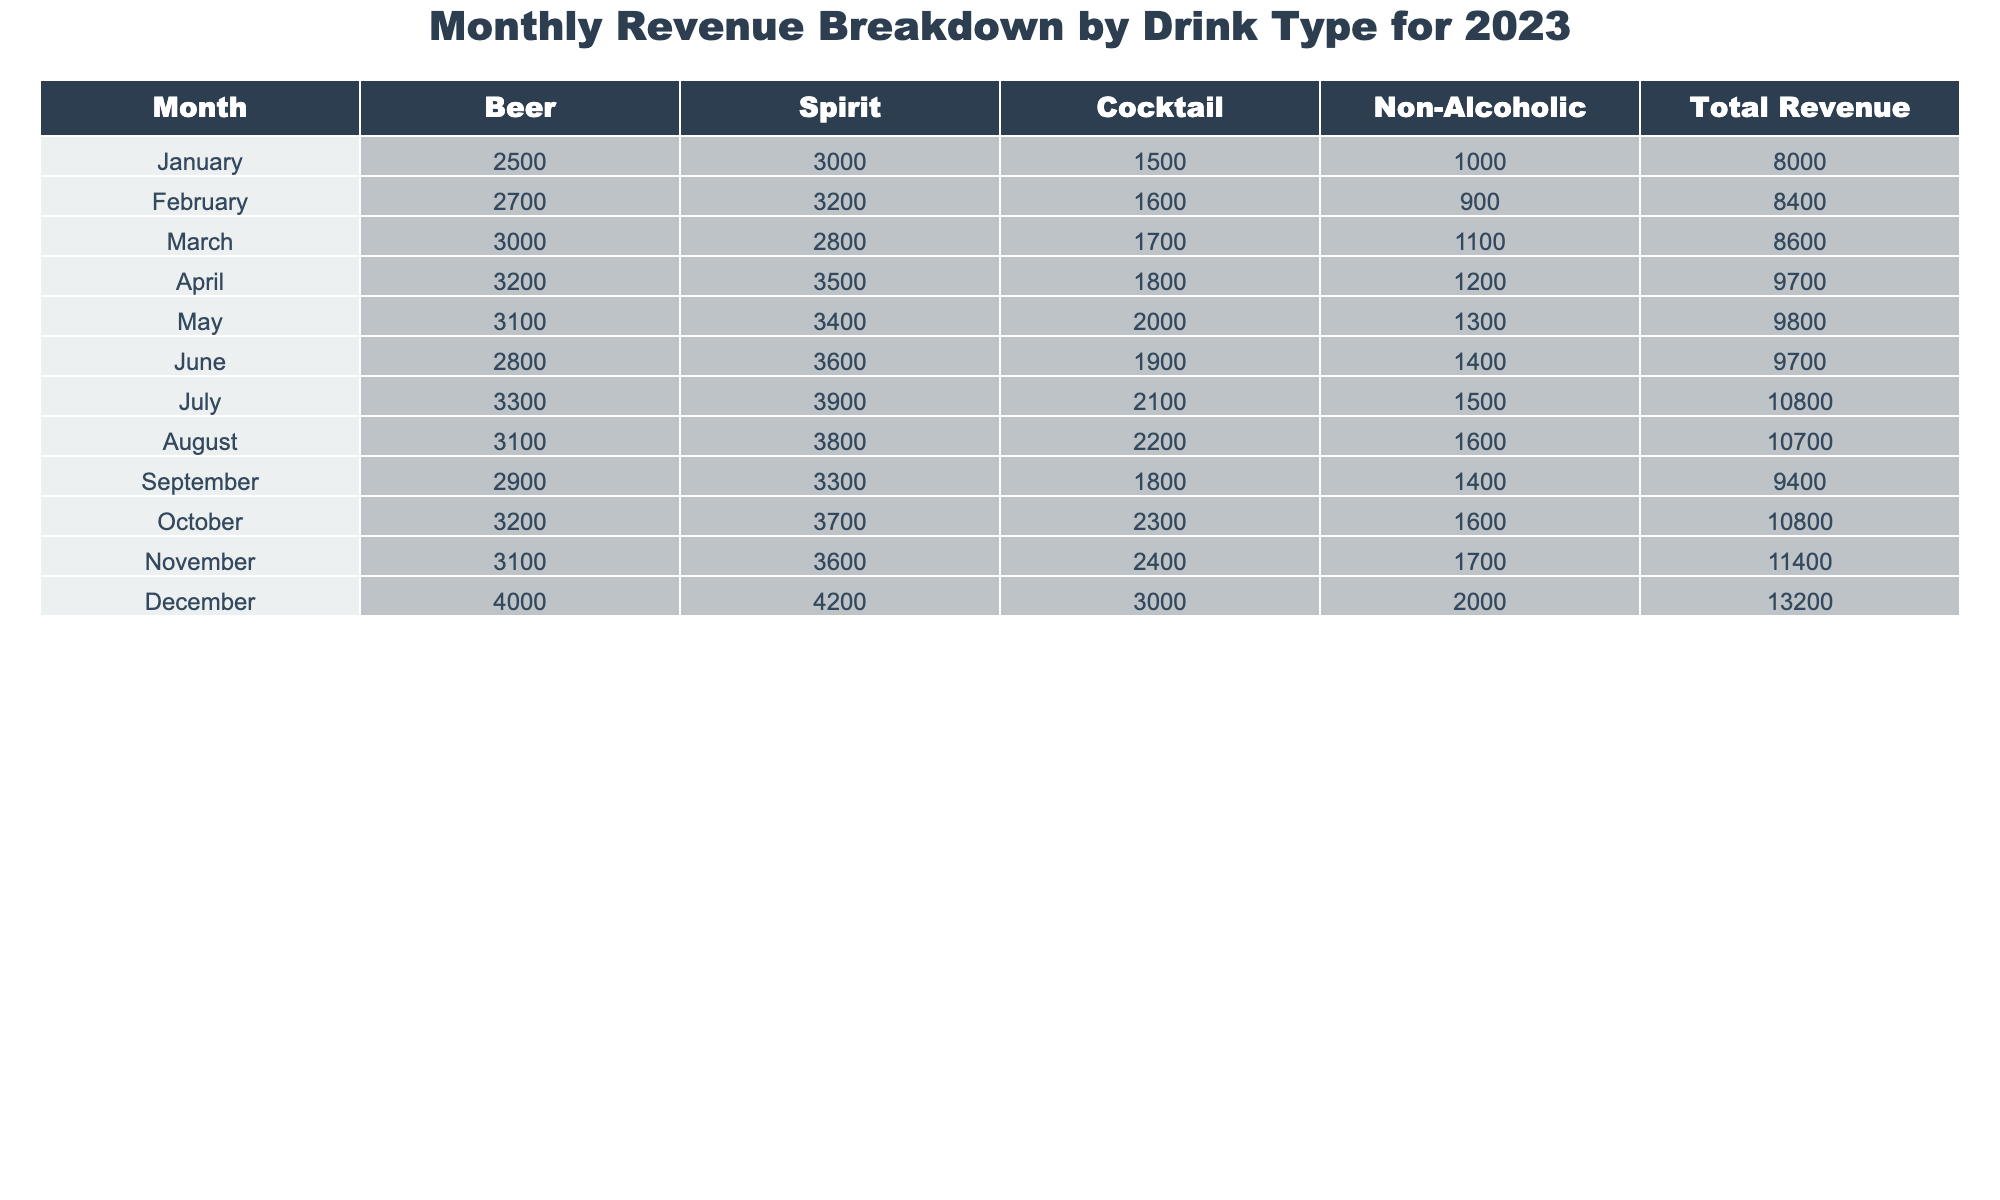What was the total revenue for December? To find the total revenue for December, we look at the row for December in the table. The value listed under 'Total Revenue' for December is $13,200.
Answer: $13,200 Which drink type generated the highest revenue in July? In July, the revenue values are: Beer $3,300, Spirit $3,900, Cocktail $2,100, and Non-Alcoholic $1,500. The highest revenue among these is for Spirit.
Answer: Spirit What is the average revenue from Beer for the year? We sum the revenues from Beer for each month: (2500 + 2700 + 3000 + 3200 + 3100 + 2800 + 3300 + 3100 + 2900 + 3200 + 3100 + 4000) = 36,800. There are 12 months, so the average is 36,800 / 12 = 3,066.67.
Answer: $3,066.67 In which month did Non-Alcoholic drinks generate the least revenue? By looking at the Non-Alcoholic revenue column for each month, the values are: 1,000, 900, 1,100, 1,200, 1,300, 1,400, 1,500, 1,600, 1,400, 1,600, 1,700, and 2,000. The minimum value is 900 in February.
Answer: February What is the total revenue generated from Cocktails between March and June? To get the total revenue from Cocktails from March to June, we add the values for those months: 1,700 (March) + 1,800 (April) + 2,000 (May) + 1,900 (June) = 7,400.
Answer: $7,400 Did the total revenue ever exceed $11,000 in any month? By examining the Total Revenue column, the months where total revenue exceeds $11,000 are July, November, and December ($10,800, $11,400, and $13,200 respectively). Therefore, it's true that total revenue exceeded $11,000 in those months.
Answer: Yes What was the difference in total revenue between the highest and lowest months? The highest total revenue is $13,200 in December and the lowest is $8,000 in January. The difference is $13,200 - $8,000 = $5,200.
Answer: $5,200 What percentage of the total revenue in March came from Spirits? The total revenue in March is $8,600, with Spirits generating $2,800. To find the percentage, we calculate (2,800 / 8,600) * 100 = 32.56%.
Answer: 32.56% Which month saw the largest increase in total revenue compared to the previous month? To find the largest increase, we calculate the differences between consecutive months: February - January: $8400 - $8000 = $400; March - February: $8600 - $8400 = $200; April - March: $9700 - $8600 = $1100; May - April: $9800 - $9700 = $100; and so on. The largest increase is $1,100 from March to April.
Answer: March to April How much revenue was generated from Spirits in the second half of the year (July - December)? Adding the Spirit revenues for July ($3,900), August ($3,800), September ($3,300), October ($3,700), November ($3,600), and December ($4,200) gives us: $3,900 + $3,800 + $3,300 + $3,700 + $3,600 + $4,200 = $22,600.
Answer: $22,600 